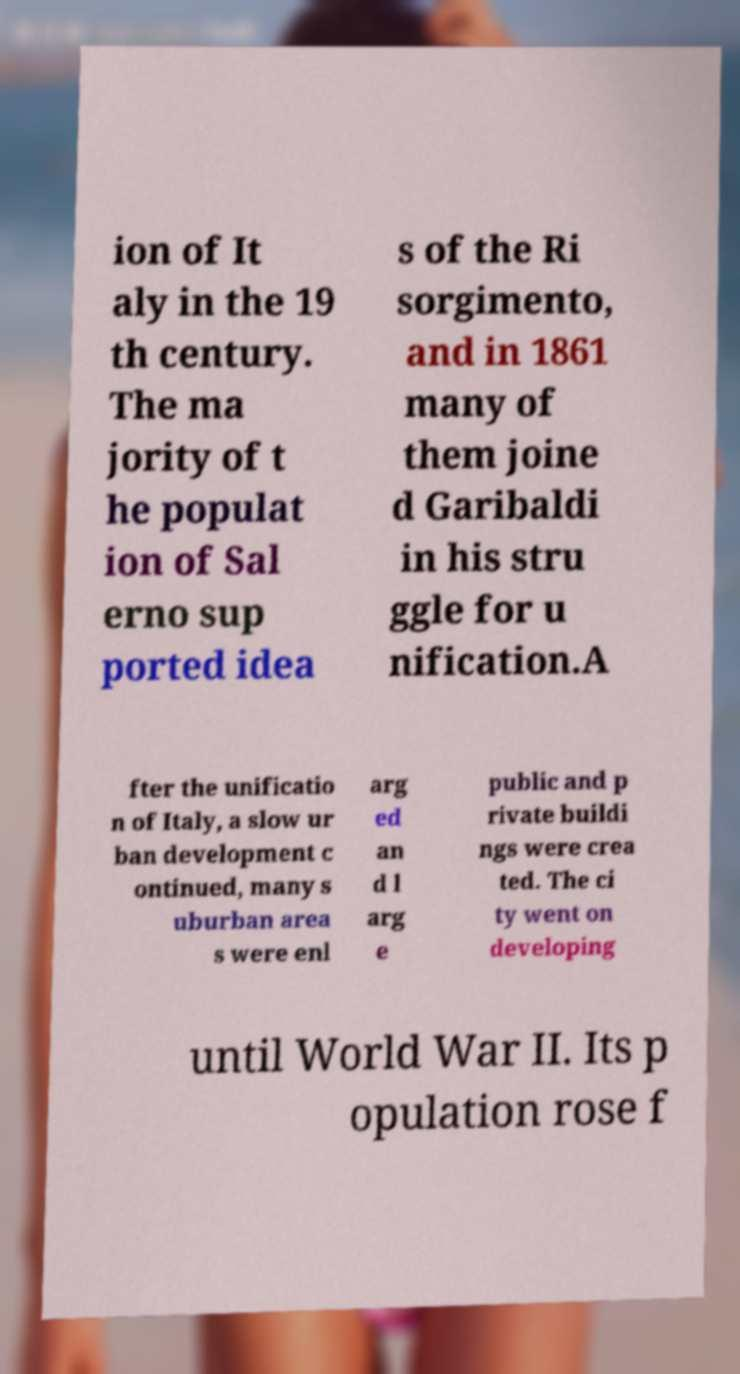For documentation purposes, I need the text within this image transcribed. Could you provide that? ion of It aly in the 19 th century. The ma jority of t he populat ion of Sal erno sup ported idea s of the Ri sorgimento, and in 1861 many of them joine d Garibaldi in his stru ggle for u nification.A fter the unificatio n of Italy, a slow ur ban development c ontinued, many s uburban area s were enl arg ed an d l arg e public and p rivate buildi ngs were crea ted. The ci ty went on developing until World War II. Its p opulation rose f 